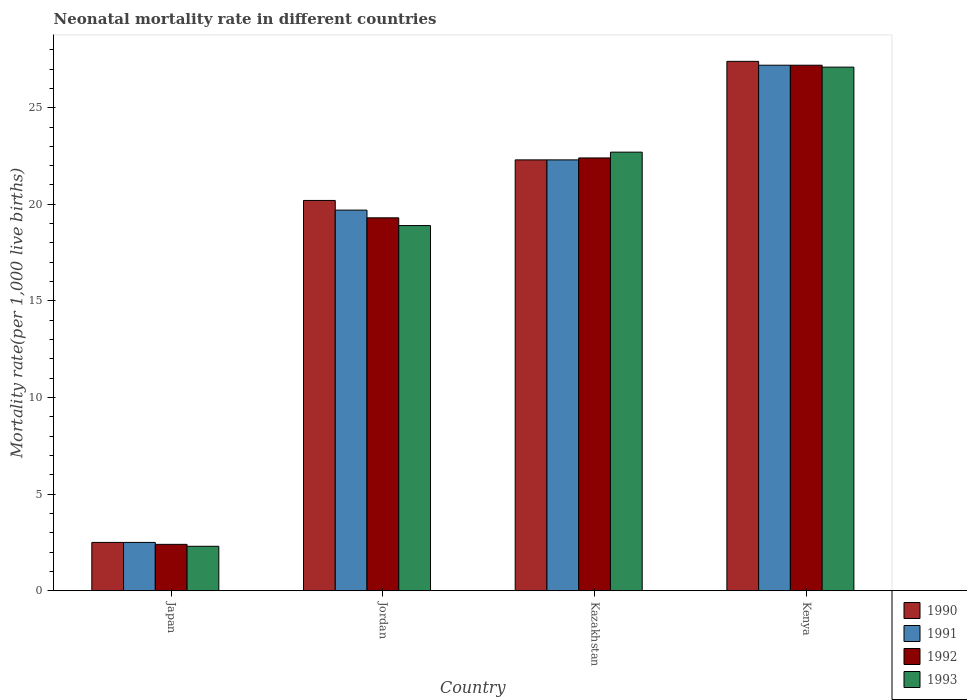How many different coloured bars are there?
Ensure brevity in your answer.  4. Are the number of bars per tick equal to the number of legend labels?
Your answer should be very brief. Yes. Are the number of bars on each tick of the X-axis equal?
Keep it short and to the point. Yes. How many bars are there on the 4th tick from the right?
Your response must be concise. 4. What is the label of the 3rd group of bars from the left?
Offer a terse response. Kazakhstan. In how many cases, is the number of bars for a given country not equal to the number of legend labels?
Give a very brief answer. 0. What is the neonatal mortality rate in 1991 in Kenya?
Offer a terse response. 27.2. Across all countries, what is the maximum neonatal mortality rate in 1992?
Offer a terse response. 27.2. In which country was the neonatal mortality rate in 1990 maximum?
Keep it short and to the point. Kenya. In which country was the neonatal mortality rate in 1993 minimum?
Your answer should be compact. Japan. What is the total neonatal mortality rate in 1992 in the graph?
Your response must be concise. 71.3. What is the difference between the neonatal mortality rate in 1992 in Jordan and that in Kazakhstan?
Ensure brevity in your answer.  -3.1. What is the difference between the neonatal mortality rate in 1993 in Kenya and the neonatal mortality rate in 1990 in Kazakhstan?
Make the answer very short. 4.8. What is the average neonatal mortality rate in 1991 per country?
Provide a succinct answer. 17.93. What is the difference between the neonatal mortality rate of/in 1991 and neonatal mortality rate of/in 1993 in Kazakhstan?
Your answer should be very brief. -0.4. In how many countries, is the neonatal mortality rate in 1993 greater than 2?
Provide a short and direct response. 4. What is the ratio of the neonatal mortality rate in 1991 in Kazakhstan to that in Kenya?
Make the answer very short. 0.82. Is the neonatal mortality rate in 1991 in Japan less than that in Kenya?
Make the answer very short. Yes. Is the difference between the neonatal mortality rate in 1991 in Jordan and Kenya greater than the difference between the neonatal mortality rate in 1993 in Jordan and Kenya?
Make the answer very short. Yes. What is the difference between the highest and the second highest neonatal mortality rate in 1990?
Offer a terse response. 7.2. What is the difference between the highest and the lowest neonatal mortality rate in 1990?
Make the answer very short. 24.9. In how many countries, is the neonatal mortality rate in 1991 greater than the average neonatal mortality rate in 1991 taken over all countries?
Provide a succinct answer. 3. Is the sum of the neonatal mortality rate in 1990 in Jordan and Kazakhstan greater than the maximum neonatal mortality rate in 1992 across all countries?
Give a very brief answer. Yes. What does the 3rd bar from the left in Kenya represents?
Offer a very short reply. 1992. How many bars are there?
Ensure brevity in your answer.  16. Are all the bars in the graph horizontal?
Offer a terse response. No. What is the difference between two consecutive major ticks on the Y-axis?
Provide a succinct answer. 5. Are the values on the major ticks of Y-axis written in scientific E-notation?
Your answer should be compact. No. How many legend labels are there?
Your response must be concise. 4. What is the title of the graph?
Provide a succinct answer. Neonatal mortality rate in different countries. What is the label or title of the Y-axis?
Offer a very short reply. Mortality rate(per 1,0 live births). What is the Mortality rate(per 1,000 live births) of 1991 in Japan?
Make the answer very short. 2.5. What is the Mortality rate(per 1,000 live births) in 1993 in Japan?
Your answer should be very brief. 2.3. What is the Mortality rate(per 1,000 live births) of 1990 in Jordan?
Make the answer very short. 20.2. What is the Mortality rate(per 1,000 live births) of 1992 in Jordan?
Your answer should be compact. 19.3. What is the Mortality rate(per 1,000 live births) of 1993 in Jordan?
Keep it short and to the point. 18.9. What is the Mortality rate(per 1,000 live births) of 1990 in Kazakhstan?
Your answer should be compact. 22.3. What is the Mortality rate(per 1,000 live births) in 1991 in Kazakhstan?
Offer a very short reply. 22.3. What is the Mortality rate(per 1,000 live births) of 1992 in Kazakhstan?
Your answer should be compact. 22.4. What is the Mortality rate(per 1,000 live births) of 1993 in Kazakhstan?
Offer a terse response. 22.7. What is the Mortality rate(per 1,000 live births) of 1990 in Kenya?
Give a very brief answer. 27.4. What is the Mortality rate(per 1,000 live births) of 1991 in Kenya?
Offer a terse response. 27.2. What is the Mortality rate(per 1,000 live births) of 1992 in Kenya?
Your response must be concise. 27.2. What is the Mortality rate(per 1,000 live births) in 1993 in Kenya?
Provide a short and direct response. 27.1. Across all countries, what is the maximum Mortality rate(per 1,000 live births) of 1990?
Make the answer very short. 27.4. Across all countries, what is the maximum Mortality rate(per 1,000 live births) of 1991?
Your answer should be compact. 27.2. Across all countries, what is the maximum Mortality rate(per 1,000 live births) of 1992?
Ensure brevity in your answer.  27.2. Across all countries, what is the maximum Mortality rate(per 1,000 live births) in 1993?
Offer a very short reply. 27.1. Across all countries, what is the minimum Mortality rate(per 1,000 live births) of 1991?
Offer a very short reply. 2.5. Across all countries, what is the minimum Mortality rate(per 1,000 live births) of 1992?
Provide a succinct answer. 2.4. Across all countries, what is the minimum Mortality rate(per 1,000 live births) of 1993?
Your response must be concise. 2.3. What is the total Mortality rate(per 1,000 live births) of 1990 in the graph?
Your answer should be very brief. 72.4. What is the total Mortality rate(per 1,000 live births) of 1991 in the graph?
Your answer should be very brief. 71.7. What is the total Mortality rate(per 1,000 live births) of 1992 in the graph?
Provide a short and direct response. 71.3. What is the total Mortality rate(per 1,000 live births) in 1993 in the graph?
Your answer should be compact. 71. What is the difference between the Mortality rate(per 1,000 live births) in 1990 in Japan and that in Jordan?
Offer a terse response. -17.7. What is the difference between the Mortality rate(per 1,000 live births) in 1991 in Japan and that in Jordan?
Your answer should be very brief. -17.2. What is the difference between the Mortality rate(per 1,000 live births) in 1992 in Japan and that in Jordan?
Offer a terse response. -16.9. What is the difference between the Mortality rate(per 1,000 live births) in 1993 in Japan and that in Jordan?
Make the answer very short. -16.6. What is the difference between the Mortality rate(per 1,000 live births) of 1990 in Japan and that in Kazakhstan?
Your answer should be compact. -19.8. What is the difference between the Mortality rate(per 1,000 live births) of 1991 in Japan and that in Kazakhstan?
Make the answer very short. -19.8. What is the difference between the Mortality rate(per 1,000 live births) in 1992 in Japan and that in Kazakhstan?
Offer a terse response. -20. What is the difference between the Mortality rate(per 1,000 live births) in 1993 in Japan and that in Kazakhstan?
Your answer should be compact. -20.4. What is the difference between the Mortality rate(per 1,000 live births) in 1990 in Japan and that in Kenya?
Keep it short and to the point. -24.9. What is the difference between the Mortality rate(per 1,000 live births) of 1991 in Japan and that in Kenya?
Ensure brevity in your answer.  -24.7. What is the difference between the Mortality rate(per 1,000 live births) of 1992 in Japan and that in Kenya?
Provide a short and direct response. -24.8. What is the difference between the Mortality rate(per 1,000 live births) of 1993 in Japan and that in Kenya?
Offer a terse response. -24.8. What is the difference between the Mortality rate(per 1,000 live births) in 1990 in Jordan and that in Kazakhstan?
Ensure brevity in your answer.  -2.1. What is the difference between the Mortality rate(per 1,000 live births) in 1991 in Jordan and that in Kazakhstan?
Ensure brevity in your answer.  -2.6. What is the difference between the Mortality rate(per 1,000 live births) in 1992 in Jordan and that in Kazakhstan?
Provide a short and direct response. -3.1. What is the difference between the Mortality rate(per 1,000 live births) in 1993 in Jordan and that in Kazakhstan?
Give a very brief answer. -3.8. What is the difference between the Mortality rate(per 1,000 live births) in 1990 in Jordan and that in Kenya?
Your response must be concise. -7.2. What is the difference between the Mortality rate(per 1,000 live births) in 1992 in Jordan and that in Kenya?
Your answer should be compact. -7.9. What is the difference between the Mortality rate(per 1,000 live births) in 1992 in Kazakhstan and that in Kenya?
Keep it short and to the point. -4.8. What is the difference between the Mortality rate(per 1,000 live births) of 1993 in Kazakhstan and that in Kenya?
Ensure brevity in your answer.  -4.4. What is the difference between the Mortality rate(per 1,000 live births) of 1990 in Japan and the Mortality rate(per 1,000 live births) of 1991 in Jordan?
Offer a very short reply. -17.2. What is the difference between the Mortality rate(per 1,000 live births) of 1990 in Japan and the Mortality rate(per 1,000 live births) of 1992 in Jordan?
Ensure brevity in your answer.  -16.8. What is the difference between the Mortality rate(per 1,000 live births) of 1990 in Japan and the Mortality rate(per 1,000 live births) of 1993 in Jordan?
Provide a short and direct response. -16.4. What is the difference between the Mortality rate(per 1,000 live births) of 1991 in Japan and the Mortality rate(per 1,000 live births) of 1992 in Jordan?
Your answer should be compact. -16.8. What is the difference between the Mortality rate(per 1,000 live births) in 1991 in Japan and the Mortality rate(per 1,000 live births) in 1993 in Jordan?
Give a very brief answer. -16.4. What is the difference between the Mortality rate(per 1,000 live births) in 1992 in Japan and the Mortality rate(per 1,000 live births) in 1993 in Jordan?
Provide a short and direct response. -16.5. What is the difference between the Mortality rate(per 1,000 live births) in 1990 in Japan and the Mortality rate(per 1,000 live births) in 1991 in Kazakhstan?
Provide a succinct answer. -19.8. What is the difference between the Mortality rate(per 1,000 live births) in 1990 in Japan and the Mortality rate(per 1,000 live births) in 1992 in Kazakhstan?
Give a very brief answer. -19.9. What is the difference between the Mortality rate(per 1,000 live births) in 1990 in Japan and the Mortality rate(per 1,000 live births) in 1993 in Kazakhstan?
Ensure brevity in your answer.  -20.2. What is the difference between the Mortality rate(per 1,000 live births) in 1991 in Japan and the Mortality rate(per 1,000 live births) in 1992 in Kazakhstan?
Provide a short and direct response. -19.9. What is the difference between the Mortality rate(per 1,000 live births) of 1991 in Japan and the Mortality rate(per 1,000 live births) of 1993 in Kazakhstan?
Provide a succinct answer. -20.2. What is the difference between the Mortality rate(per 1,000 live births) of 1992 in Japan and the Mortality rate(per 1,000 live births) of 1993 in Kazakhstan?
Give a very brief answer. -20.3. What is the difference between the Mortality rate(per 1,000 live births) of 1990 in Japan and the Mortality rate(per 1,000 live births) of 1991 in Kenya?
Keep it short and to the point. -24.7. What is the difference between the Mortality rate(per 1,000 live births) in 1990 in Japan and the Mortality rate(per 1,000 live births) in 1992 in Kenya?
Ensure brevity in your answer.  -24.7. What is the difference between the Mortality rate(per 1,000 live births) in 1990 in Japan and the Mortality rate(per 1,000 live births) in 1993 in Kenya?
Provide a short and direct response. -24.6. What is the difference between the Mortality rate(per 1,000 live births) of 1991 in Japan and the Mortality rate(per 1,000 live births) of 1992 in Kenya?
Your response must be concise. -24.7. What is the difference between the Mortality rate(per 1,000 live births) in 1991 in Japan and the Mortality rate(per 1,000 live births) in 1993 in Kenya?
Your answer should be compact. -24.6. What is the difference between the Mortality rate(per 1,000 live births) in 1992 in Japan and the Mortality rate(per 1,000 live births) in 1993 in Kenya?
Provide a succinct answer. -24.7. What is the difference between the Mortality rate(per 1,000 live births) of 1990 in Jordan and the Mortality rate(per 1,000 live births) of 1992 in Kazakhstan?
Provide a short and direct response. -2.2. What is the difference between the Mortality rate(per 1,000 live births) in 1990 in Jordan and the Mortality rate(per 1,000 live births) in 1993 in Kazakhstan?
Your response must be concise. -2.5. What is the difference between the Mortality rate(per 1,000 live births) of 1990 in Jordan and the Mortality rate(per 1,000 live births) of 1992 in Kenya?
Ensure brevity in your answer.  -7. What is the difference between the Mortality rate(per 1,000 live births) in 1991 in Jordan and the Mortality rate(per 1,000 live births) in 1992 in Kenya?
Offer a terse response. -7.5. What is the difference between the Mortality rate(per 1,000 live births) in 1991 in Jordan and the Mortality rate(per 1,000 live births) in 1993 in Kenya?
Keep it short and to the point. -7.4. What is the difference between the Mortality rate(per 1,000 live births) in 1992 in Jordan and the Mortality rate(per 1,000 live births) in 1993 in Kenya?
Provide a succinct answer. -7.8. What is the difference between the Mortality rate(per 1,000 live births) in 1990 in Kazakhstan and the Mortality rate(per 1,000 live births) in 1991 in Kenya?
Keep it short and to the point. -4.9. What is the difference between the Mortality rate(per 1,000 live births) in 1991 in Kazakhstan and the Mortality rate(per 1,000 live births) in 1992 in Kenya?
Provide a succinct answer. -4.9. What is the average Mortality rate(per 1,000 live births) in 1991 per country?
Your answer should be compact. 17.93. What is the average Mortality rate(per 1,000 live births) of 1992 per country?
Your response must be concise. 17.82. What is the average Mortality rate(per 1,000 live births) of 1993 per country?
Provide a short and direct response. 17.75. What is the difference between the Mortality rate(per 1,000 live births) of 1990 and Mortality rate(per 1,000 live births) of 1991 in Japan?
Offer a very short reply. 0. What is the difference between the Mortality rate(per 1,000 live births) in 1990 and Mortality rate(per 1,000 live births) in 1993 in Japan?
Keep it short and to the point. 0.2. What is the difference between the Mortality rate(per 1,000 live births) in 1991 and Mortality rate(per 1,000 live births) in 1993 in Japan?
Offer a very short reply. 0.2. What is the difference between the Mortality rate(per 1,000 live births) of 1990 and Mortality rate(per 1,000 live births) of 1992 in Jordan?
Ensure brevity in your answer.  0.9. What is the difference between the Mortality rate(per 1,000 live births) of 1990 and Mortality rate(per 1,000 live births) of 1993 in Jordan?
Make the answer very short. 1.3. What is the difference between the Mortality rate(per 1,000 live births) of 1991 and Mortality rate(per 1,000 live births) of 1992 in Jordan?
Give a very brief answer. 0.4. What is the difference between the Mortality rate(per 1,000 live births) in 1992 and Mortality rate(per 1,000 live births) in 1993 in Jordan?
Your answer should be very brief. 0.4. What is the difference between the Mortality rate(per 1,000 live births) of 1990 and Mortality rate(per 1,000 live births) of 1991 in Kazakhstan?
Ensure brevity in your answer.  0. What is the difference between the Mortality rate(per 1,000 live births) of 1990 and Mortality rate(per 1,000 live births) of 1992 in Kazakhstan?
Your answer should be very brief. -0.1. What is the difference between the Mortality rate(per 1,000 live births) in 1990 and Mortality rate(per 1,000 live births) in 1993 in Kazakhstan?
Provide a succinct answer. -0.4. What is the difference between the Mortality rate(per 1,000 live births) of 1991 and Mortality rate(per 1,000 live births) of 1993 in Kazakhstan?
Make the answer very short. -0.4. What is the difference between the Mortality rate(per 1,000 live births) in 1990 and Mortality rate(per 1,000 live births) in 1993 in Kenya?
Offer a terse response. 0.3. What is the difference between the Mortality rate(per 1,000 live births) of 1992 and Mortality rate(per 1,000 live births) of 1993 in Kenya?
Give a very brief answer. 0.1. What is the ratio of the Mortality rate(per 1,000 live births) of 1990 in Japan to that in Jordan?
Offer a terse response. 0.12. What is the ratio of the Mortality rate(per 1,000 live births) of 1991 in Japan to that in Jordan?
Your answer should be compact. 0.13. What is the ratio of the Mortality rate(per 1,000 live births) in 1992 in Japan to that in Jordan?
Your answer should be compact. 0.12. What is the ratio of the Mortality rate(per 1,000 live births) of 1993 in Japan to that in Jordan?
Offer a terse response. 0.12. What is the ratio of the Mortality rate(per 1,000 live births) in 1990 in Japan to that in Kazakhstan?
Offer a very short reply. 0.11. What is the ratio of the Mortality rate(per 1,000 live births) in 1991 in Japan to that in Kazakhstan?
Make the answer very short. 0.11. What is the ratio of the Mortality rate(per 1,000 live births) of 1992 in Japan to that in Kazakhstan?
Offer a very short reply. 0.11. What is the ratio of the Mortality rate(per 1,000 live births) of 1993 in Japan to that in Kazakhstan?
Your answer should be compact. 0.1. What is the ratio of the Mortality rate(per 1,000 live births) of 1990 in Japan to that in Kenya?
Offer a very short reply. 0.09. What is the ratio of the Mortality rate(per 1,000 live births) of 1991 in Japan to that in Kenya?
Your response must be concise. 0.09. What is the ratio of the Mortality rate(per 1,000 live births) in 1992 in Japan to that in Kenya?
Your answer should be very brief. 0.09. What is the ratio of the Mortality rate(per 1,000 live births) of 1993 in Japan to that in Kenya?
Offer a very short reply. 0.08. What is the ratio of the Mortality rate(per 1,000 live births) in 1990 in Jordan to that in Kazakhstan?
Your response must be concise. 0.91. What is the ratio of the Mortality rate(per 1,000 live births) of 1991 in Jordan to that in Kazakhstan?
Your answer should be very brief. 0.88. What is the ratio of the Mortality rate(per 1,000 live births) of 1992 in Jordan to that in Kazakhstan?
Your answer should be very brief. 0.86. What is the ratio of the Mortality rate(per 1,000 live births) of 1993 in Jordan to that in Kazakhstan?
Provide a short and direct response. 0.83. What is the ratio of the Mortality rate(per 1,000 live births) of 1990 in Jordan to that in Kenya?
Make the answer very short. 0.74. What is the ratio of the Mortality rate(per 1,000 live births) in 1991 in Jordan to that in Kenya?
Keep it short and to the point. 0.72. What is the ratio of the Mortality rate(per 1,000 live births) of 1992 in Jordan to that in Kenya?
Provide a short and direct response. 0.71. What is the ratio of the Mortality rate(per 1,000 live births) in 1993 in Jordan to that in Kenya?
Your answer should be very brief. 0.7. What is the ratio of the Mortality rate(per 1,000 live births) in 1990 in Kazakhstan to that in Kenya?
Keep it short and to the point. 0.81. What is the ratio of the Mortality rate(per 1,000 live births) of 1991 in Kazakhstan to that in Kenya?
Give a very brief answer. 0.82. What is the ratio of the Mortality rate(per 1,000 live births) of 1992 in Kazakhstan to that in Kenya?
Give a very brief answer. 0.82. What is the ratio of the Mortality rate(per 1,000 live births) in 1993 in Kazakhstan to that in Kenya?
Keep it short and to the point. 0.84. What is the difference between the highest and the second highest Mortality rate(per 1,000 live births) of 1992?
Provide a succinct answer. 4.8. What is the difference between the highest and the lowest Mortality rate(per 1,000 live births) of 1990?
Your answer should be compact. 24.9. What is the difference between the highest and the lowest Mortality rate(per 1,000 live births) of 1991?
Offer a terse response. 24.7. What is the difference between the highest and the lowest Mortality rate(per 1,000 live births) of 1992?
Make the answer very short. 24.8. What is the difference between the highest and the lowest Mortality rate(per 1,000 live births) in 1993?
Ensure brevity in your answer.  24.8. 